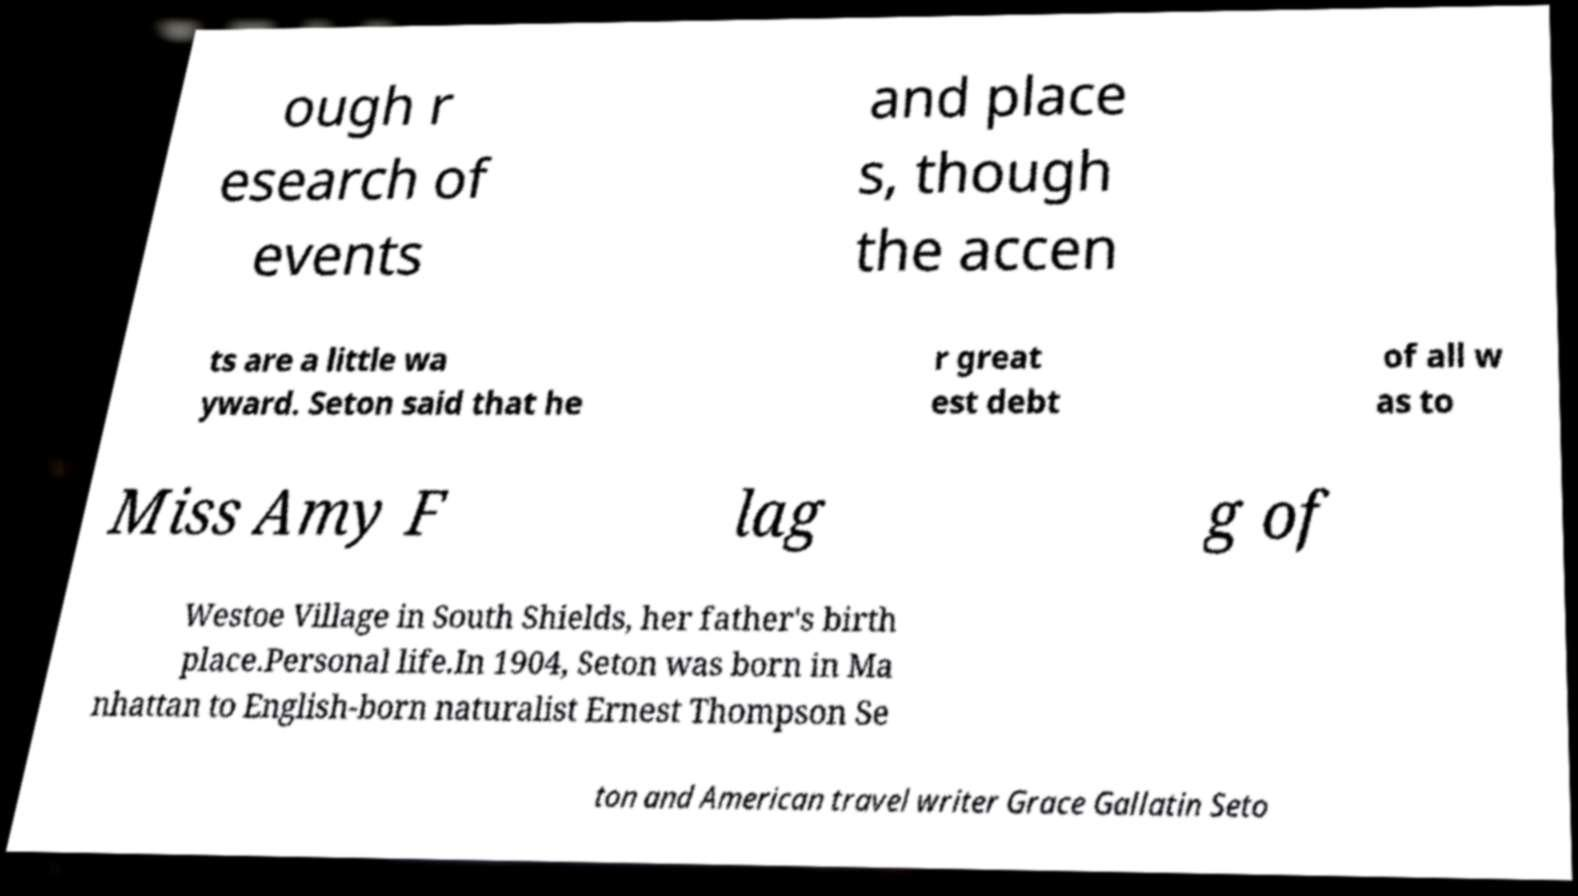What messages or text are displayed in this image? I need them in a readable, typed format. ough r esearch of events and place s, though the accen ts are a little wa yward. Seton said that he r great est debt of all w as to Miss Amy F lag g of Westoe Village in South Shields, her father's birth place.Personal life.In 1904, Seton was born in Ma nhattan to English-born naturalist Ernest Thompson Se ton and American travel writer Grace Gallatin Seto 